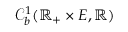Convert formula to latex. <formula><loc_0><loc_0><loc_500><loc_500>\mathcal { C } _ { b } ^ { 1 } ( \mathbb { R } _ { + } \times E , \mathbb { R } )</formula> 